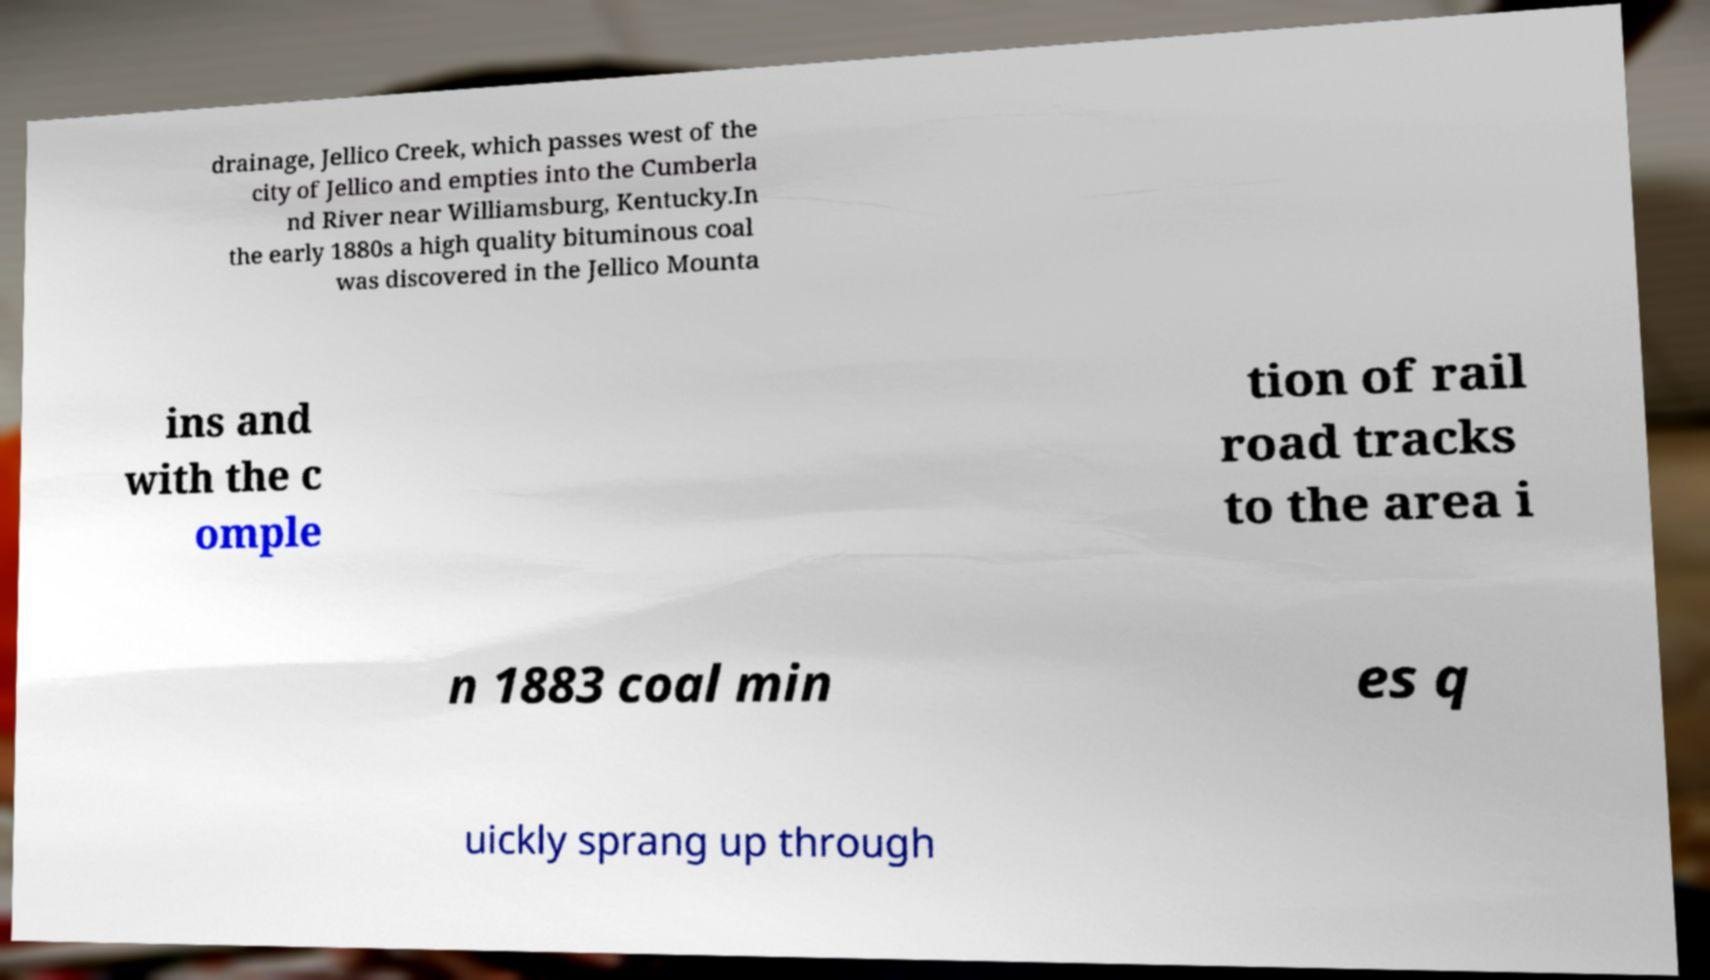What messages or text are displayed in this image? I need them in a readable, typed format. drainage, Jellico Creek, which passes west of the city of Jellico and empties into the Cumberla nd River near Williamsburg, Kentucky.In the early 1880s a high quality bituminous coal was discovered in the Jellico Mounta ins and with the c omple tion of rail road tracks to the area i n 1883 coal min es q uickly sprang up through 